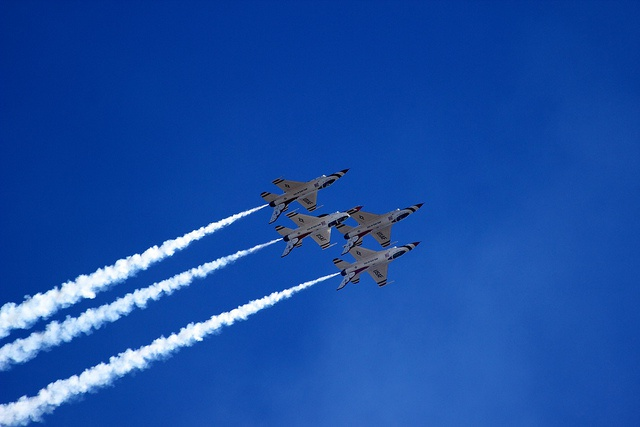Describe the objects in this image and their specific colors. I can see airplane in darkblue, gray, black, and blue tones, airplane in darkblue, gray, blue, and black tones, airplane in darkblue, gray, black, and navy tones, and airplane in darkblue, gray, and black tones in this image. 